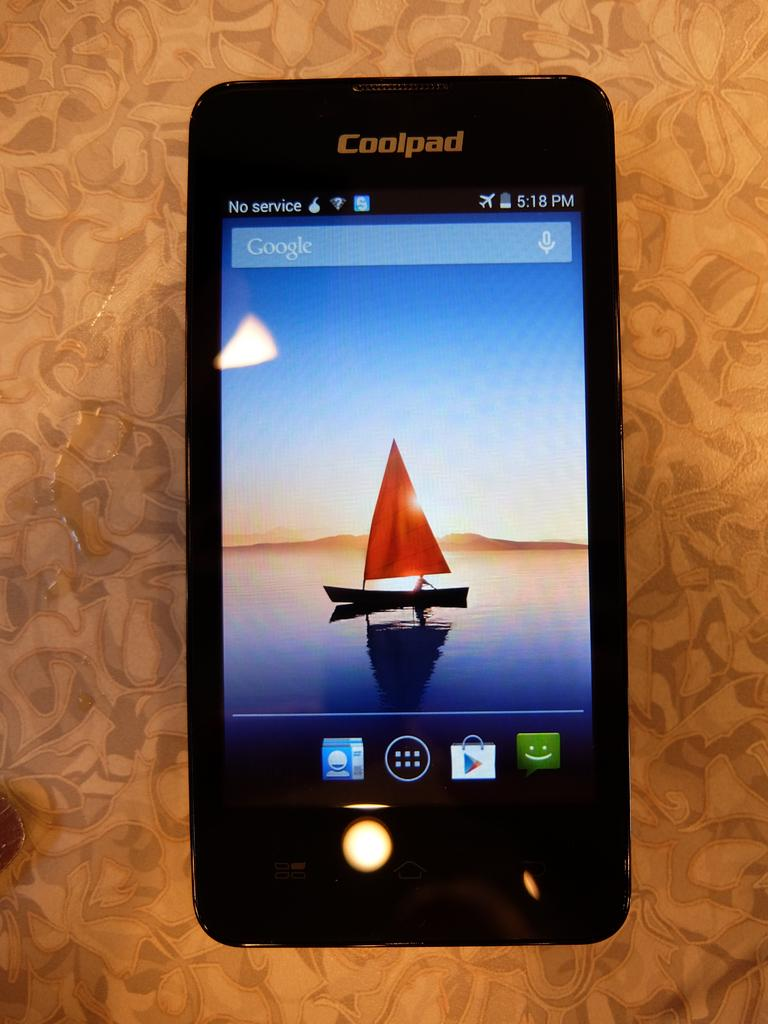<image>
Write a terse but informative summary of the picture. A Coolpad ssmartphone has a Google Search bar on the screen and shows the time as 5:18 pm. 